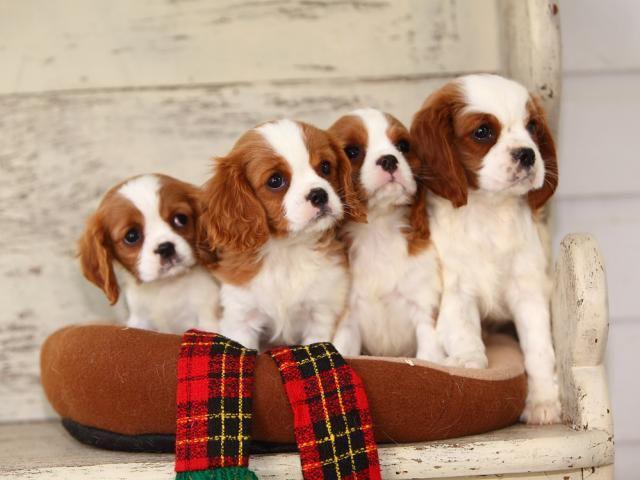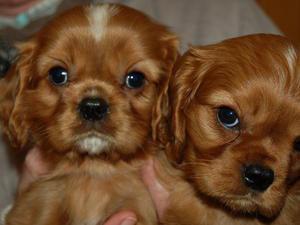The first image is the image on the left, the second image is the image on the right. Examine the images to the left and right. Is the description "There are 4 or more puppies being displayed on a cushion." accurate? Answer yes or no. Yes. The first image is the image on the left, the second image is the image on the right. Examine the images to the left and right. Is the description "There are two dogs with black ears and two dogs with brown ears sitting in a row in the image on the left." accurate? Answer yes or no. No. 